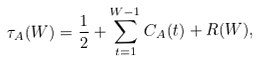<formula> <loc_0><loc_0><loc_500><loc_500>\tau _ { A } ( W ) = \frac { 1 } { 2 } + \sum _ { t = 1 } ^ { W - 1 } C _ { A } ( t ) + R ( W ) ,</formula> 